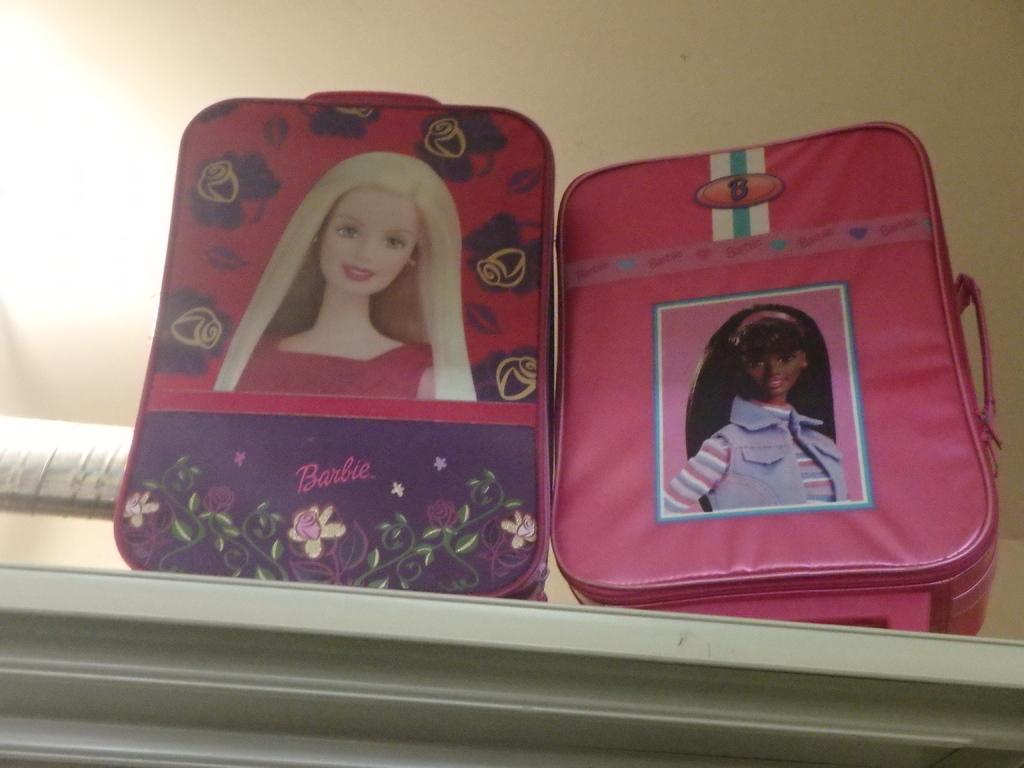What objects are present in the image that are related to Barbie? There are two Barbie pouches in the image. Where are the Barbie pouches located? The Barbie pouches are on a counter. What can be seen in the background of the image? There is a wall visible in the background of the image. What is the chance of winning a pen in the industry depicted in the image? There is no reference to a pen, winning, or an industry in the image, so it's not possible to determine the chance of winning a pen in the depicted industry. 